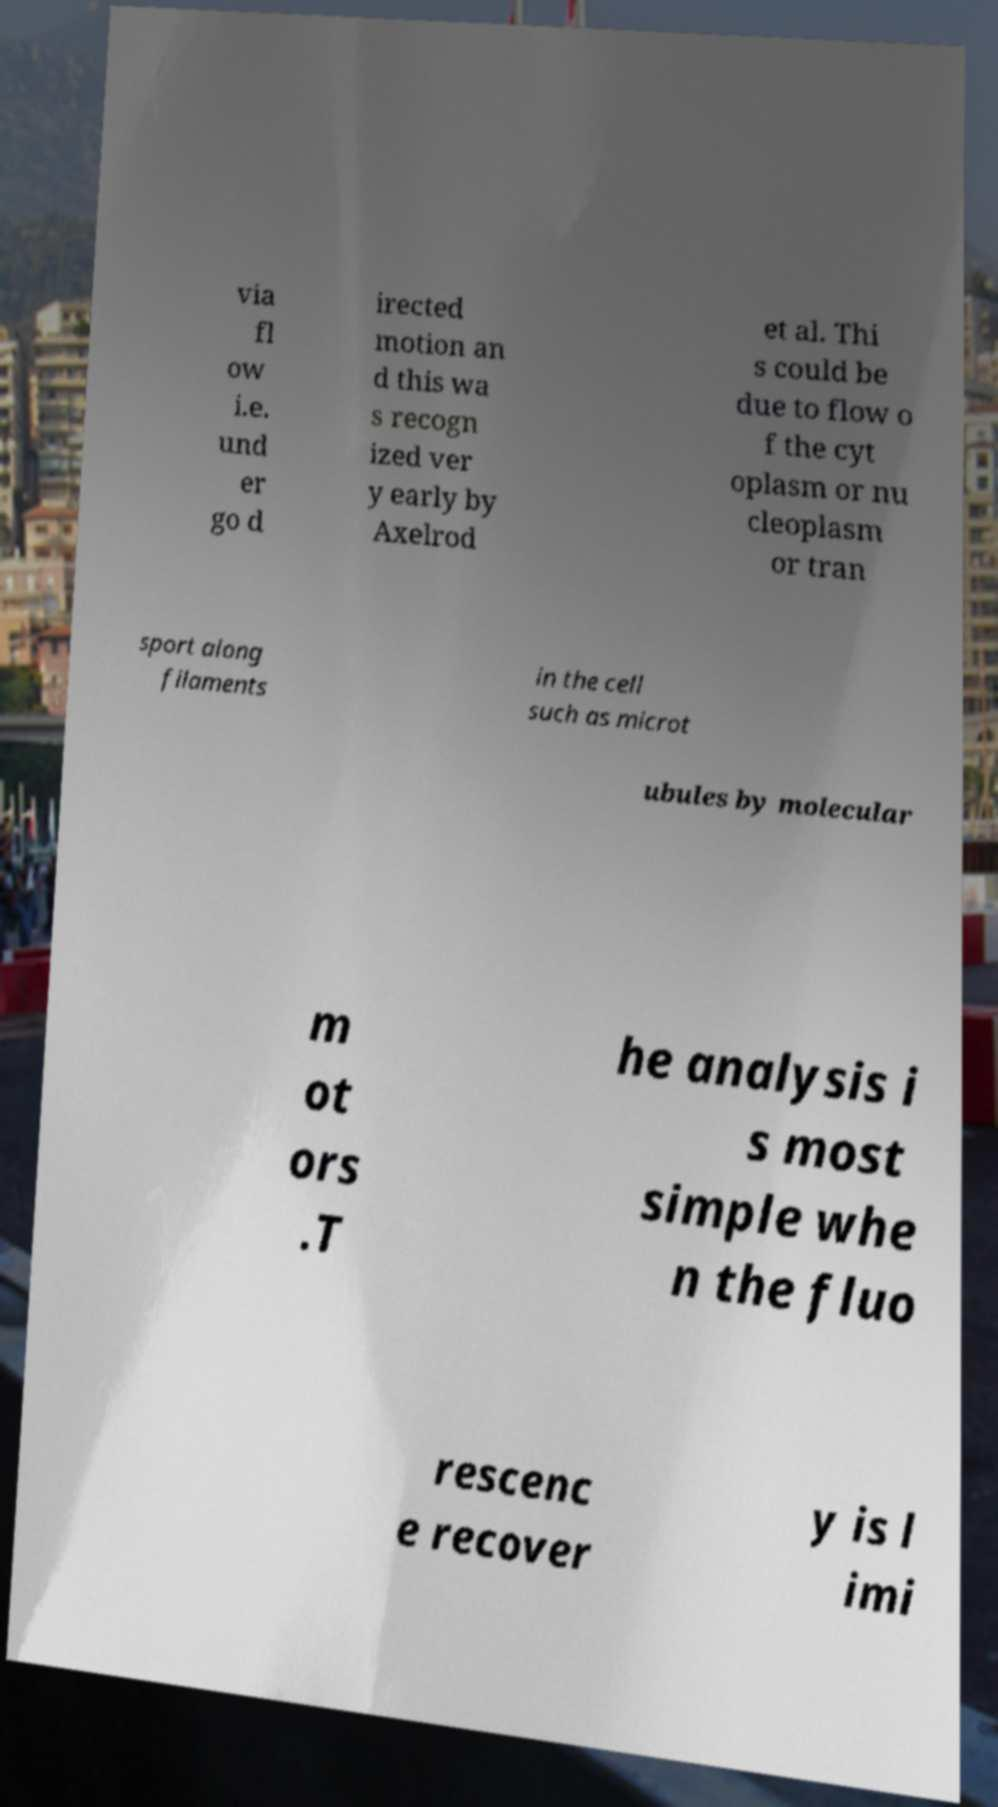Could you extract and type out the text from this image? via fl ow i.e. und er go d irected motion an d this wa s recogn ized ver y early by Axelrod et al. Thi s could be due to flow o f the cyt oplasm or nu cleoplasm or tran sport along filaments in the cell such as microt ubules by molecular m ot ors .T he analysis i s most simple whe n the fluo rescenc e recover y is l imi 